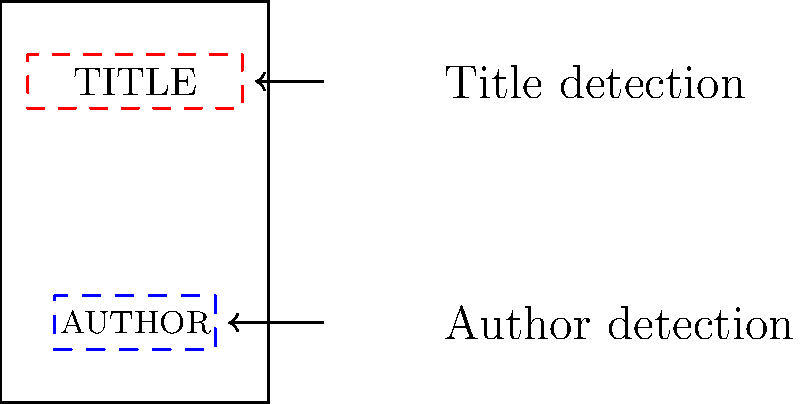In computer vision-based typography analysis for book covers, which of the following techniques would be most effective for detecting and analyzing the placement of title and author text, considering the minimalist design approach?

A) Convolutional Neural Networks (CNNs)
B) Optical Character Recognition (OCR)
C) Region-based Convolutional Neural Networks (R-CNNs)
D) Template Matching To determine the most effective technique for detecting and analyzing typography placement on minimalist book covers, let's consider each option:

1. Convolutional Neural Networks (CNNs):
   - Effective for image classification and feature extraction
   - Not specifically designed for object detection or localization

2. Optical Character Recognition (OCR):
   - Primarily used for text recognition and extraction
   - May struggle with stylized or unconventional typography common in minimalist designs

3. Region-based Convolutional Neural Networks (R-CNNs):
   - Designed for object detection and localization
   - Can identify and locate specific regions of interest (e.g., title and author text areas)
   - Capable of handling various font styles and placements

4. Template Matching:
   - Relies on predefined templates
   - Less flexible for diverse minimalist designs and varying typography styles

Considering the minimalist approach, where typography placement and style can vary significantly, R-CNNs offer the most suitable solution. They can:

1. Detect and localize text regions, regardless of specific font or style
2. Adapt to different layouts and designs
3. Provide bounding boxes for title and author text areas
4. Handle the sleek and modern designs characteristic of minimalist book covers

R-CNNs combine the feature extraction capabilities of CNNs with region proposal networks, making them ideal for detecting and analyzing typography placement in various minimalist book cover designs.
Answer: Region-based Convolutional Neural Networks (R-CNNs) 